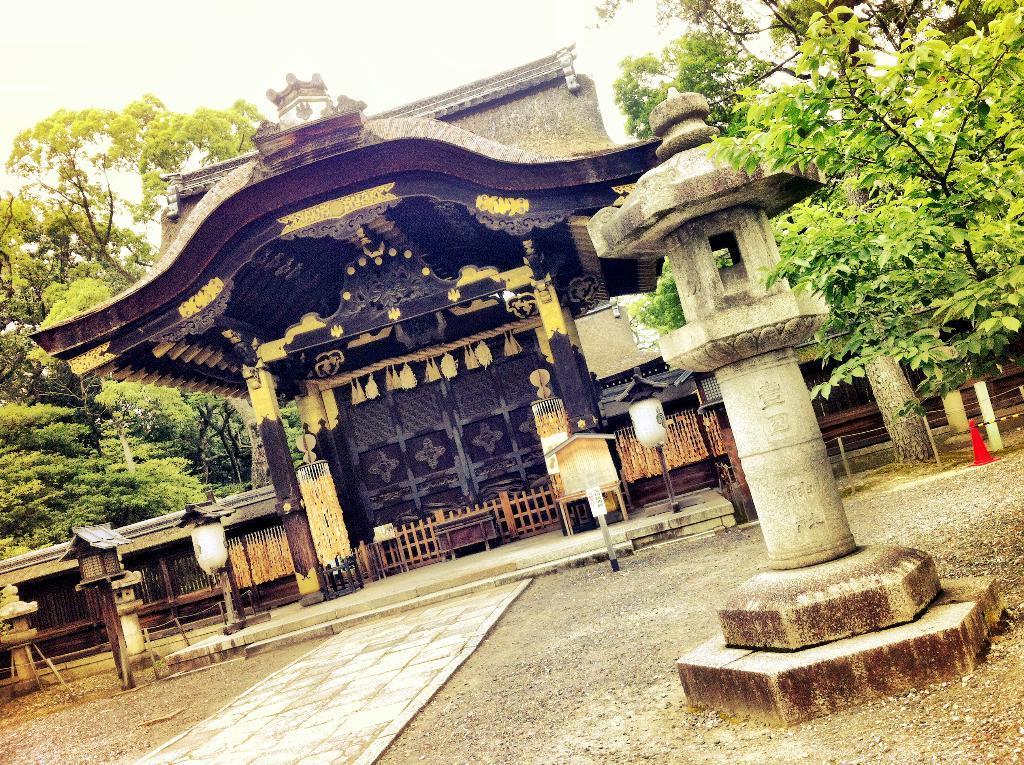In one or two sentences, can you explain what this image depicts? In this picture we can see a path, architecture, building, trees, boxes and some objects and in the background we can see the sky. 